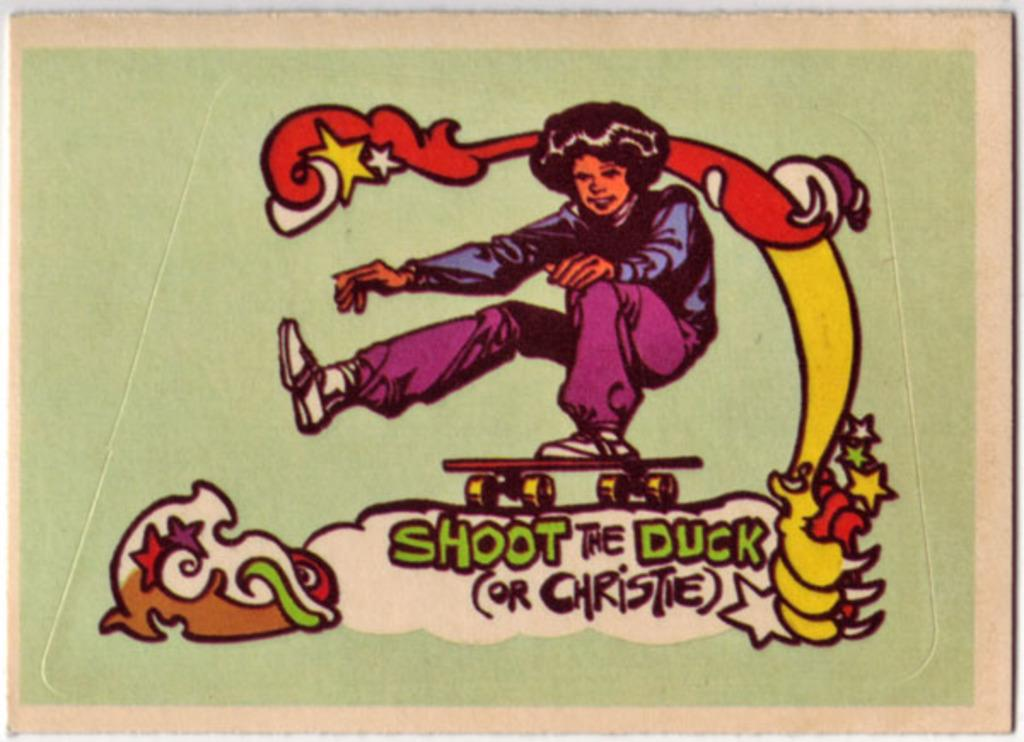What is depicted on the card in the image? The card contains a picture of a person. What else can be found on the card besides the picture? There are texts and designs on the card. What type of rule is being used to measure the depth of the basin in the image? There is no rule or basin present in the image; it only features a card with a picture, texts, and designs. What type of work is the person in the image engaged in? The image does not show the person engaged in any work; it only features a card with a picture, texts, and designs. 